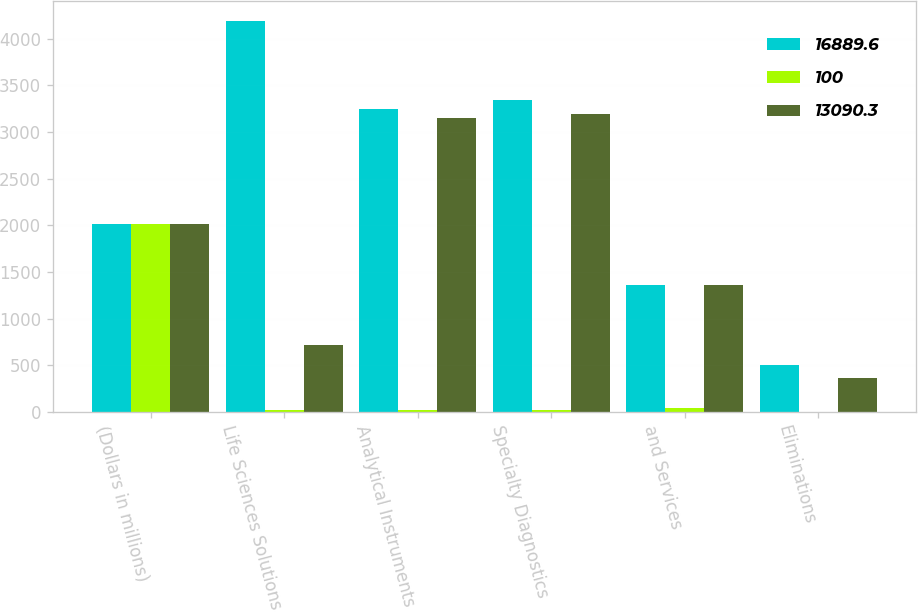<chart> <loc_0><loc_0><loc_500><loc_500><stacked_bar_chart><ecel><fcel>(Dollars in millions)<fcel>Life Sciences Solutions<fcel>Analytical Instruments<fcel>Specialty Diagnostics<fcel>and Services<fcel>Eliminations<nl><fcel>16889.6<fcel>2014<fcel>4195.7<fcel>3252.2<fcel>3343.6<fcel>1362.75<fcel>503.4<nl><fcel>100<fcel>2014<fcel>24.8<fcel>19.3<fcel>19.8<fcel>39.1<fcel>3<nl><fcel>13090.3<fcel>2013<fcel>712.5<fcel>3154.2<fcel>3191.7<fcel>1362.75<fcel>366.9<nl></chart> 